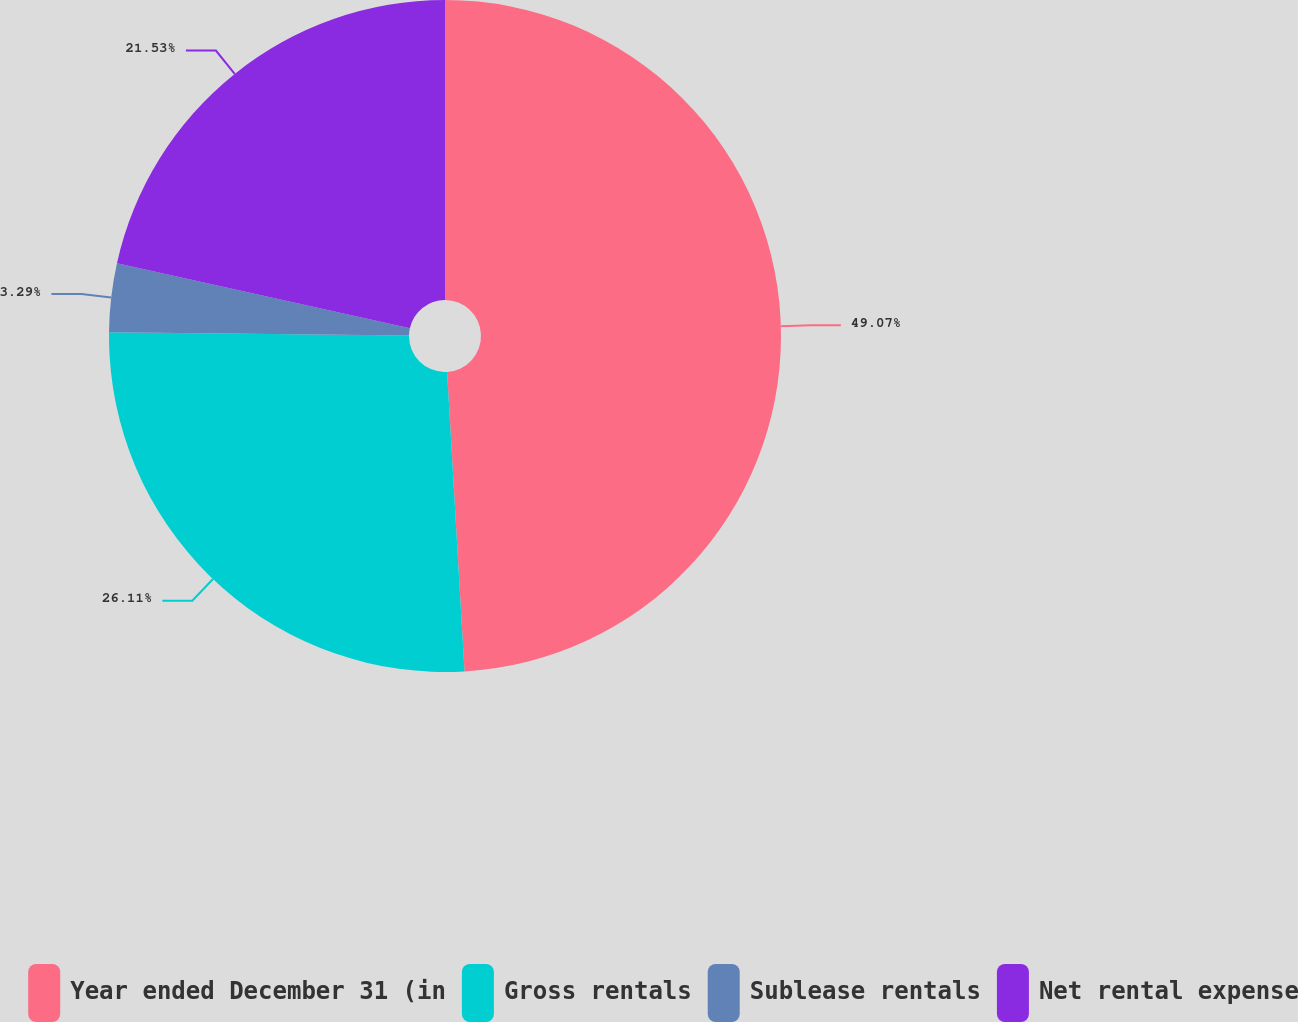Convert chart. <chart><loc_0><loc_0><loc_500><loc_500><pie_chart><fcel>Year ended December 31 (in<fcel>Gross rentals<fcel>Sublease rentals<fcel>Net rental expense<nl><fcel>49.08%<fcel>26.11%<fcel>3.29%<fcel>21.53%<nl></chart> 